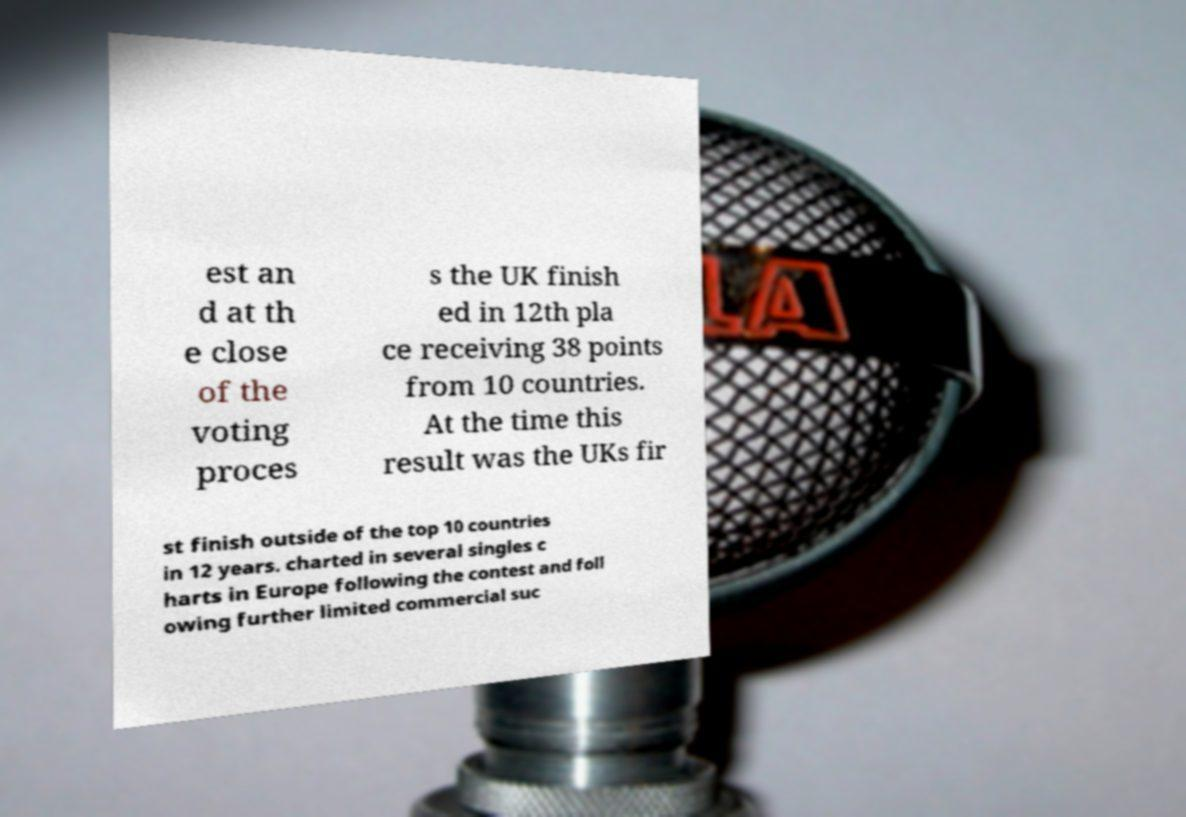Can you accurately transcribe the text from the provided image for me? est an d at th e close of the voting proces s the UK finish ed in 12th pla ce receiving 38 points from 10 countries. At the time this result was the UKs fir st finish outside of the top 10 countries in 12 years. charted in several singles c harts in Europe following the contest and foll owing further limited commercial suc 